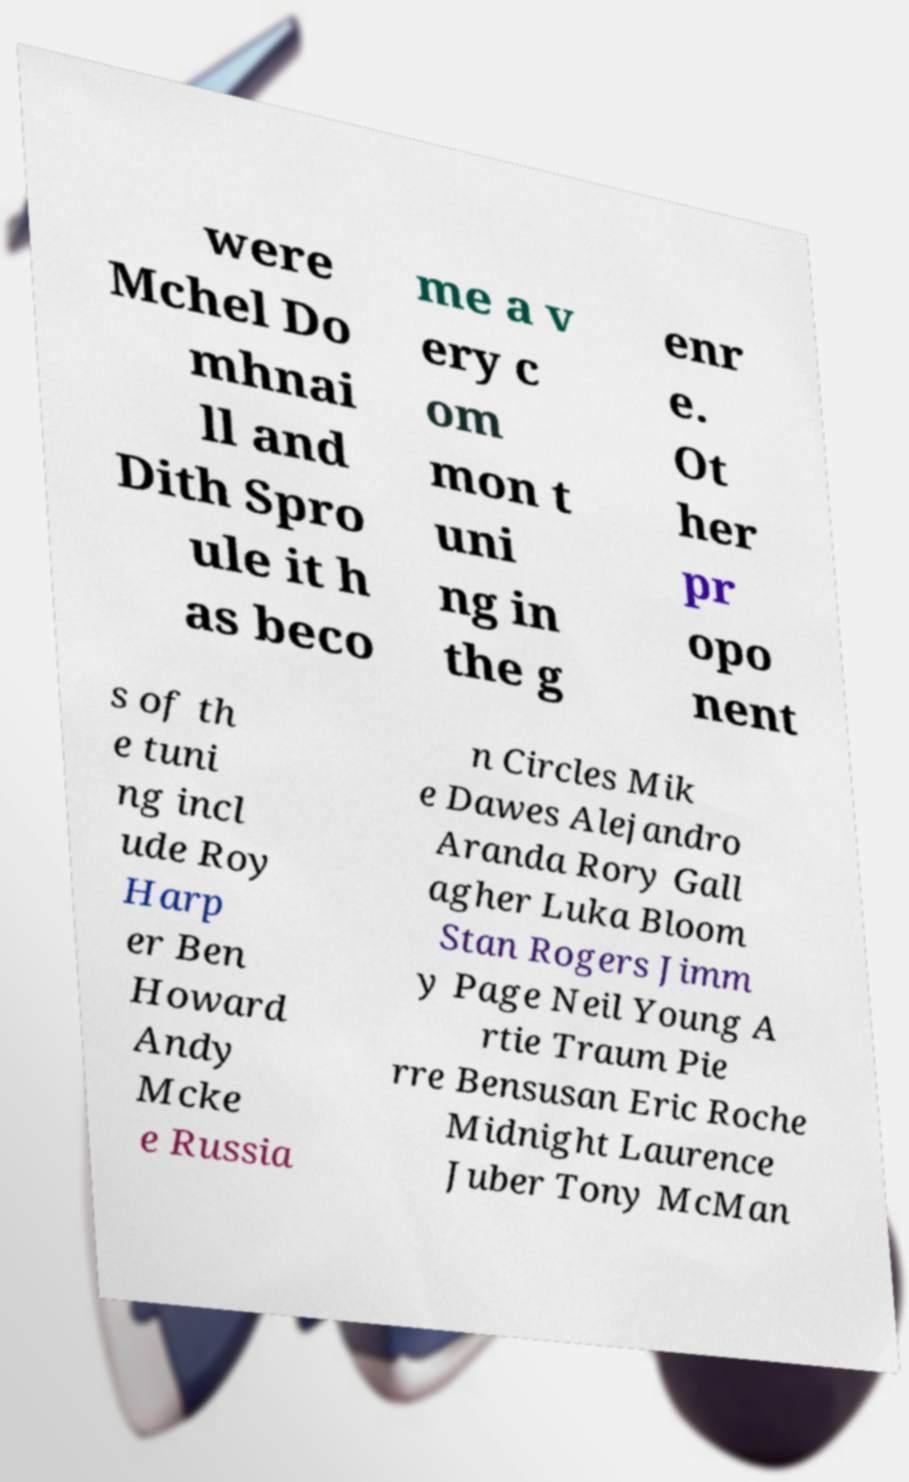What messages or text are displayed in this image? I need them in a readable, typed format. were Mchel Do mhnai ll and Dith Spro ule it h as beco me a v ery c om mon t uni ng in the g enr e. Ot her pr opo nent s of th e tuni ng incl ude Roy Harp er Ben Howard Andy Mcke e Russia n Circles Mik e Dawes Alejandro Aranda Rory Gall agher Luka Bloom Stan Rogers Jimm y Page Neil Young A rtie Traum Pie rre Bensusan Eric Roche Midnight Laurence Juber Tony McMan 